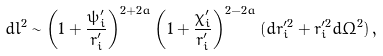Convert formula to latex. <formula><loc_0><loc_0><loc_500><loc_500>d l ^ { 2 } \sim \left ( 1 + \frac { \psi _ { i } ^ { \prime } } { r _ { i } ^ { \prime } } \right ) ^ { 2 + 2 a } \left ( 1 + \frac { \chi _ { i } ^ { \prime } } { r _ { i } ^ { \prime } } \right ) ^ { 2 - 2 a } ( d r _ { i } ^ { \prime 2 } + r _ { i } ^ { \prime 2 } d \Omega ^ { 2 } ) \, ,</formula> 